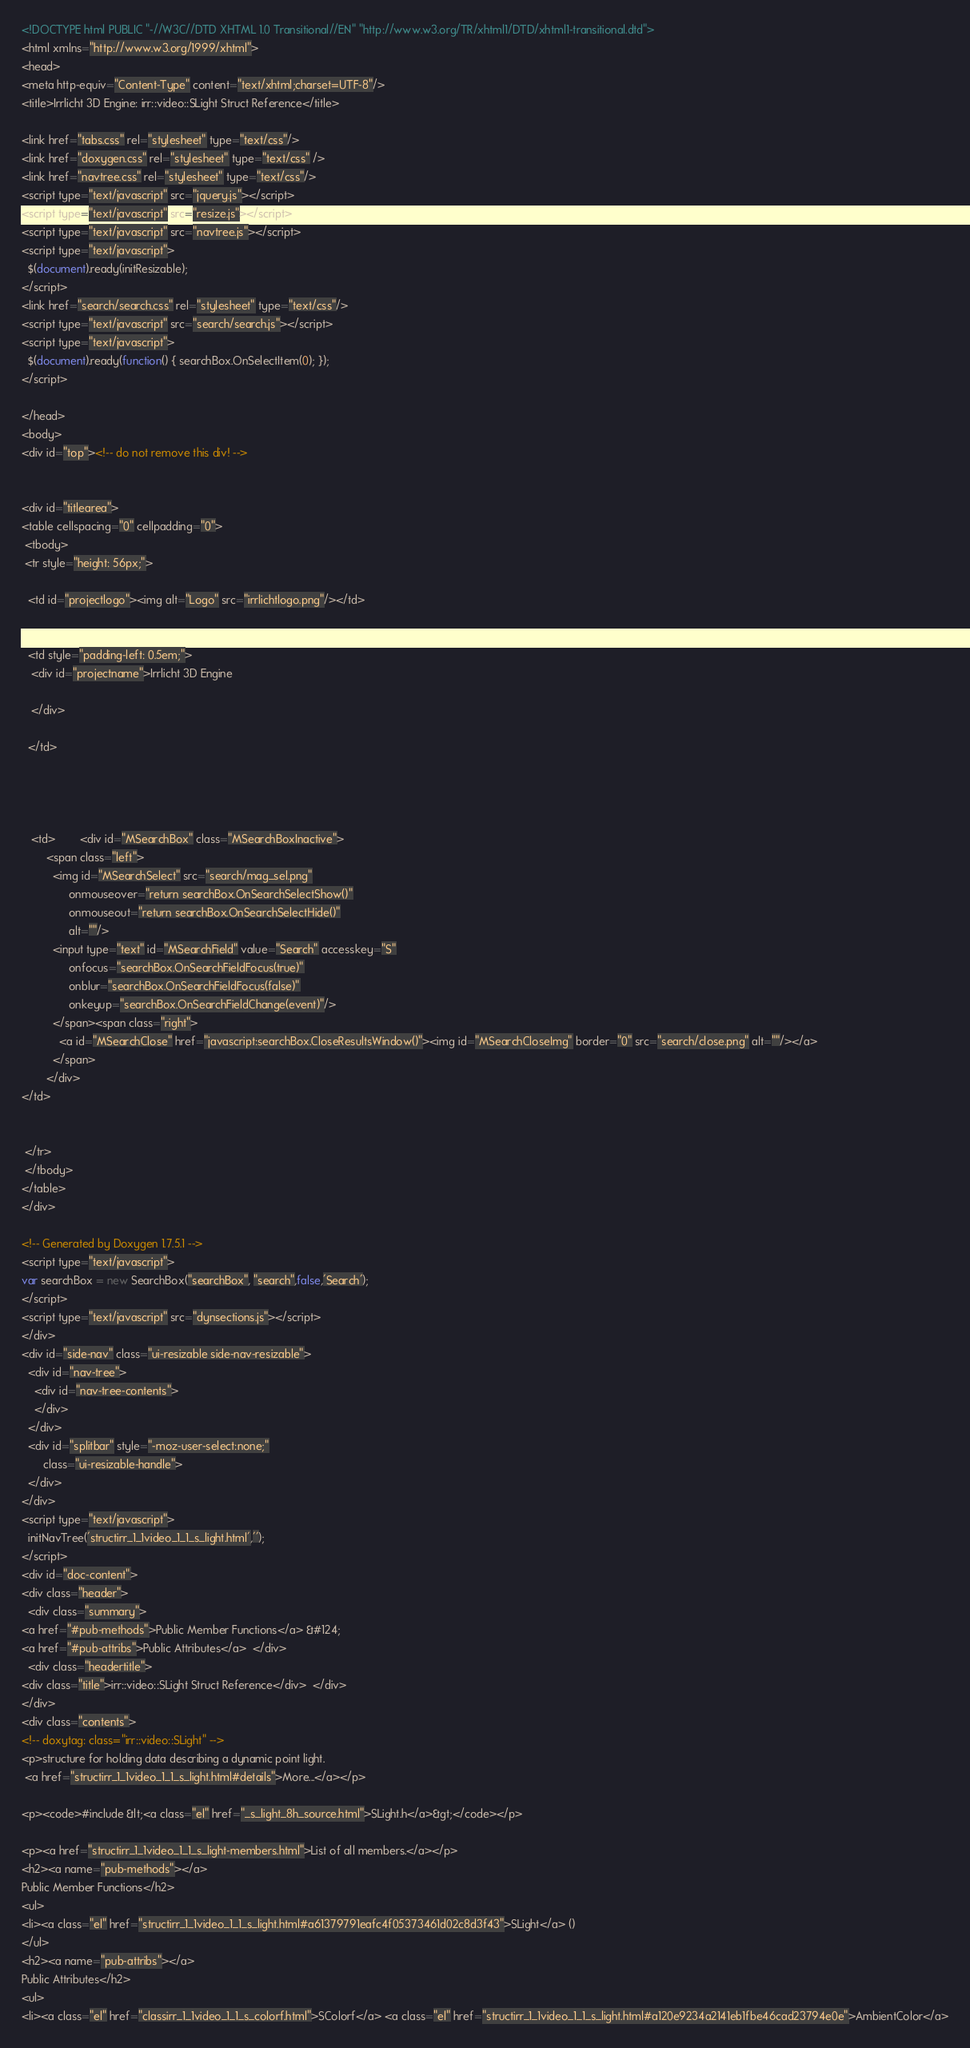<code> <loc_0><loc_0><loc_500><loc_500><_HTML_><!DOCTYPE html PUBLIC "-//W3C//DTD XHTML 1.0 Transitional//EN" "http://www.w3.org/TR/xhtml1/DTD/xhtml1-transitional.dtd">
<html xmlns="http://www.w3.org/1999/xhtml">
<head>
<meta http-equiv="Content-Type" content="text/xhtml;charset=UTF-8"/>
<title>Irrlicht 3D Engine: irr::video::SLight Struct Reference</title>

<link href="tabs.css" rel="stylesheet" type="text/css"/>
<link href="doxygen.css" rel="stylesheet" type="text/css" />
<link href="navtree.css" rel="stylesheet" type="text/css"/>
<script type="text/javascript" src="jquery.js"></script>
<script type="text/javascript" src="resize.js"></script>
<script type="text/javascript" src="navtree.js"></script>
<script type="text/javascript">
  $(document).ready(initResizable);
</script>
<link href="search/search.css" rel="stylesheet" type="text/css"/>
<script type="text/javascript" src="search/search.js"></script>
<script type="text/javascript">
  $(document).ready(function() { searchBox.OnSelectItem(0); });
</script>

</head>
<body>
<div id="top"><!-- do not remove this div! -->


<div id="titlearea">
<table cellspacing="0" cellpadding="0">
 <tbody>
 <tr style="height: 56px;">
  
  <td id="projectlogo"><img alt="Logo" src="irrlichtlogo.png"/></td>
  
  
  <td style="padding-left: 0.5em;">
   <div id="projectname">Irrlicht 3D Engine
   
   </div>
   
  </td>
  
  
  
   
   <td>        <div id="MSearchBox" class="MSearchBoxInactive">
        <span class="left">
          <img id="MSearchSelect" src="search/mag_sel.png"
               onmouseover="return searchBox.OnSearchSelectShow()"
               onmouseout="return searchBox.OnSearchSelectHide()"
               alt=""/>
          <input type="text" id="MSearchField" value="Search" accesskey="S"
               onfocus="searchBox.OnSearchFieldFocus(true)" 
               onblur="searchBox.OnSearchFieldFocus(false)" 
               onkeyup="searchBox.OnSearchFieldChange(event)"/>
          </span><span class="right">
            <a id="MSearchClose" href="javascript:searchBox.CloseResultsWindow()"><img id="MSearchCloseImg" border="0" src="search/close.png" alt=""/></a>
          </span>
        </div>
</td>
   
  
 </tr>
 </tbody>
</table>
</div>

<!-- Generated by Doxygen 1.7.5.1 -->
<script type="text/javascript">
var searchBox = new SearchBox("searchBox", "search",false,'Search');
</script>
<script type="text/javascript" src="dynsections.js"></script>
</div>
<div id="side-nav" class="ui-resizable side-nav-resizable">
  <div id="nav-tree">
    <div id="nav-tree-contents">
    </div>
  </div>
  <div id="splitbar" style="-moz-user-select:none;" 
       class="ui-resizable-handle">
  </div>
</div>
<script type="text/javascript">
  initNavTree('structirr_1_1video_1_1_s_light.html','');
</script>
<div id="doc-content">
<div class="header">
  <div class="summary">
<a href="#pub-methods">Public Member Functions</a> &#124;
<a href="#pub-attribs">Public Attributes</a>  </div>
  <div class="headertitle">
<div class="title">irr::video::SLight Struct Reference</div>  </div>
</div>
<div class="contents">
<!-- doxytag: class="irr::video::SLight" -->
<p>structure for holding data describing a dynamic point light.  
 <a href="structirr_1_1video_1_1_s_light.html#details">More...</a></p>

<p><code>#include &lt;<a class="el" href="_s_light_8h_source.html">SLight.h</a>&gt;</code></p>

<p><a href="structirr_1_1video_1_1_s_light-members.html">List of all members.</a></p>
<h2><a name="pub-methods"></a>
Public Member Functions</h2>
<ul>
<li><a class="el" href="structirr_1_1video_1_1_s_light.html#a61379791eafc4f05373461d02c8d3f43">SLight</a> ()
</ul>
<h2><a name="pub-attribs"></a>
Public Attributes</h2>
<ul>
<li><a class="el" href="classirr_1_1video_1_1_s_colorf.html">SColorf</a> <a class="el" href="structirr_1_1video_1_1_s_light.html#a120e9234a2141eb1fbe46cad23794e0e">AmbientColor</a></code> 